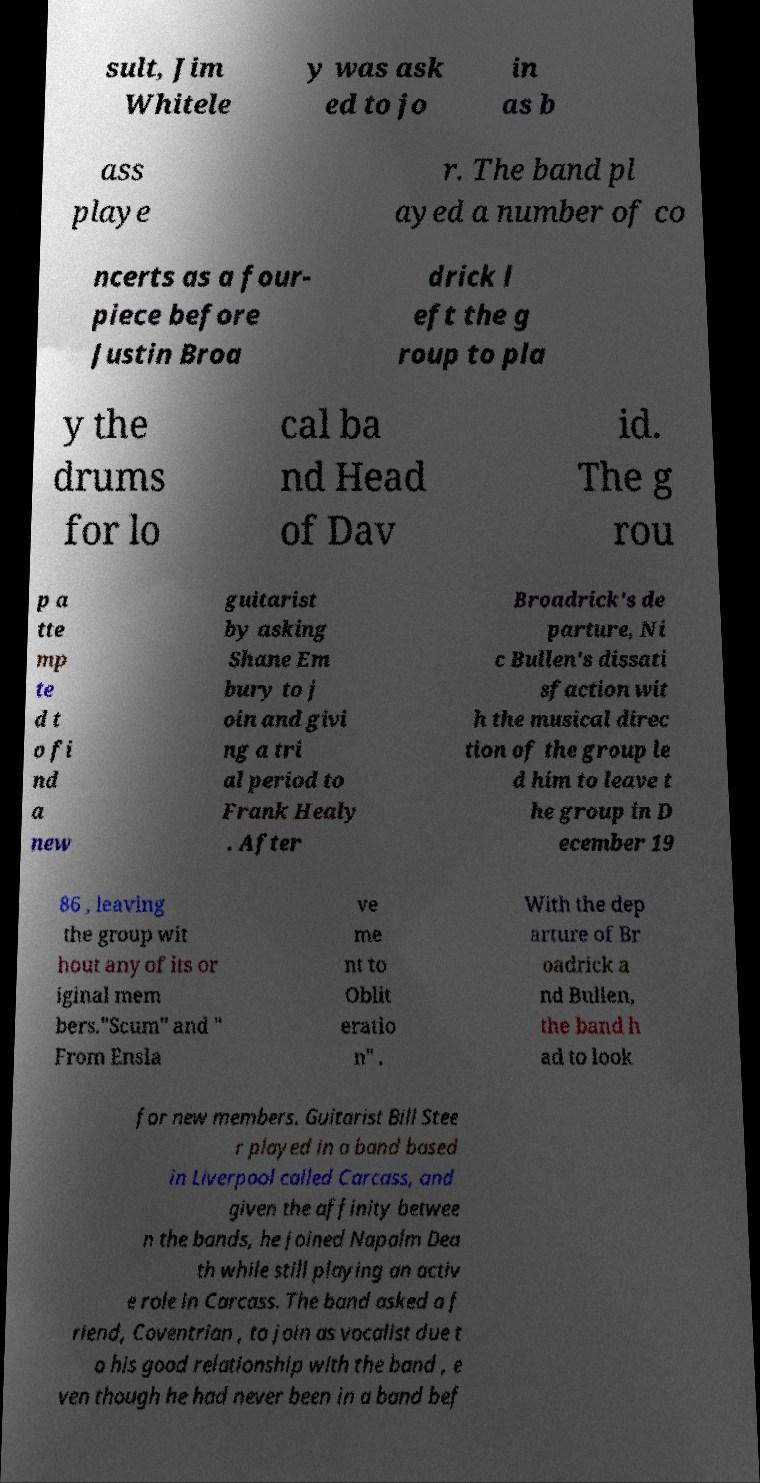For documentation purposes, I need the text within this image transcribed. Could you provide that? sult, Jim Whitele y was ask ed to jo in as b ass playe r. The band pl ayed a number of co ncerts as a four- piece before Justin Broa drick l eft the g roup to pla y the drums for lo cal ba nd Head of Dav id. The g rou p a tte mp te d t o fi nd a new guitarist by asking Shane Em bury to j oin and givi ng a tri al period to Frank Healy . After Broadrick's de parture, Ni c Bullen's dissati sfaction wit h the musical direc tion of the group le d him to leave t he group in D ecember 19 86 , leaving the group wit hout any of its or iginal mem bers."Scum" and " From Ensla ve me nt to Oblit eratio n" . With the dep arture of Br oadrick a nd Bullen, the band h ad to look for new members. Guitarist Bill Stee r played in a band based in Liverpool called Carcass, and given the affinity betwee n the bands, he joined Napalm Dea th while still playing an activ e role in Carcass. The band asked a f riend, Coventrian , to join as vocalist due t o his good relationship with the band , e ven though he had never been in a band bef 